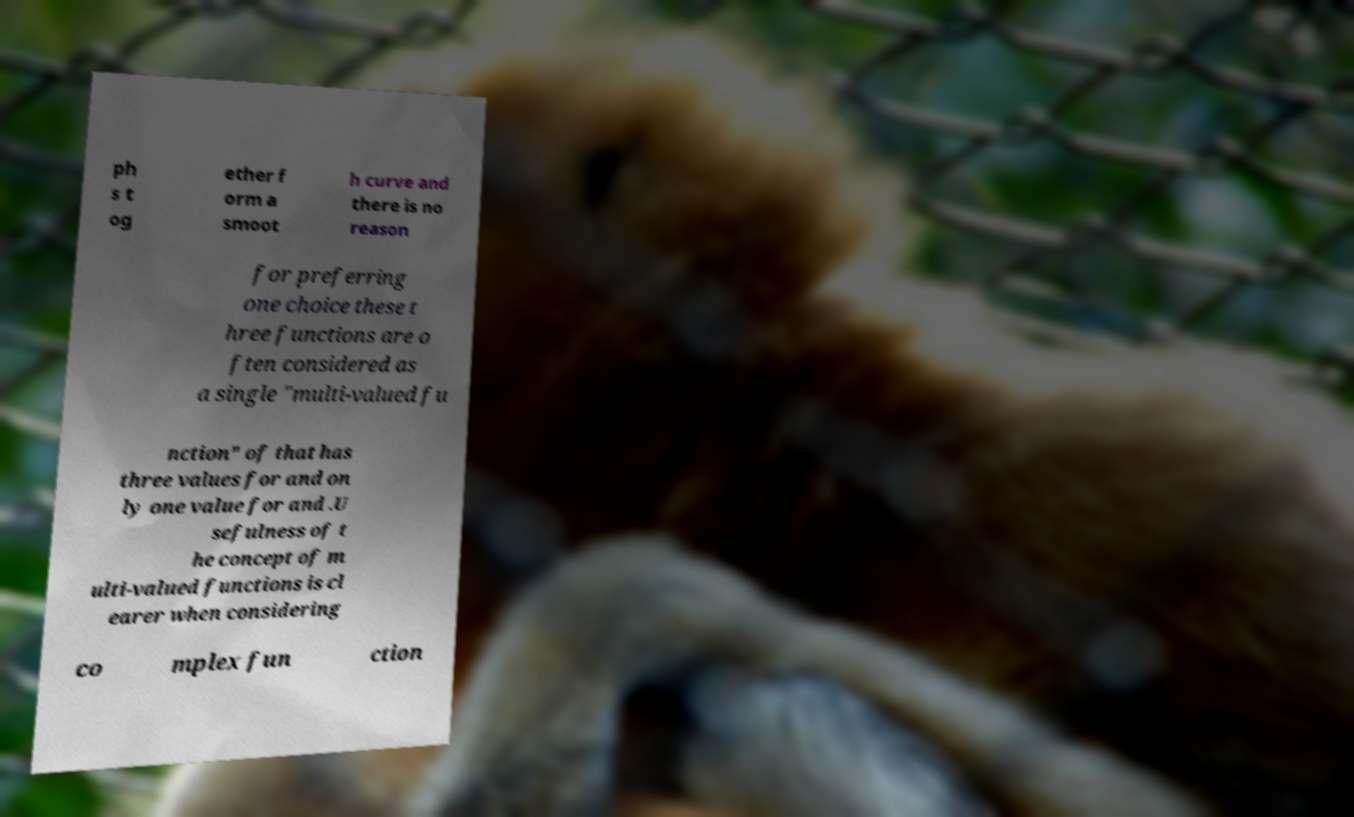There's text embedded in this image that I need extracted. Can you transcribe it verbatim? ph s t og ether f orm a smoot h curve and there is no reason for preferring one choice these t hree functions are o ften considered as a single "multi-valued fu nction" of that has three values for and on ly one value for and .U sefulness of t he concept of m ulti-valued functions is cl earer when considering co mplex fun ction 